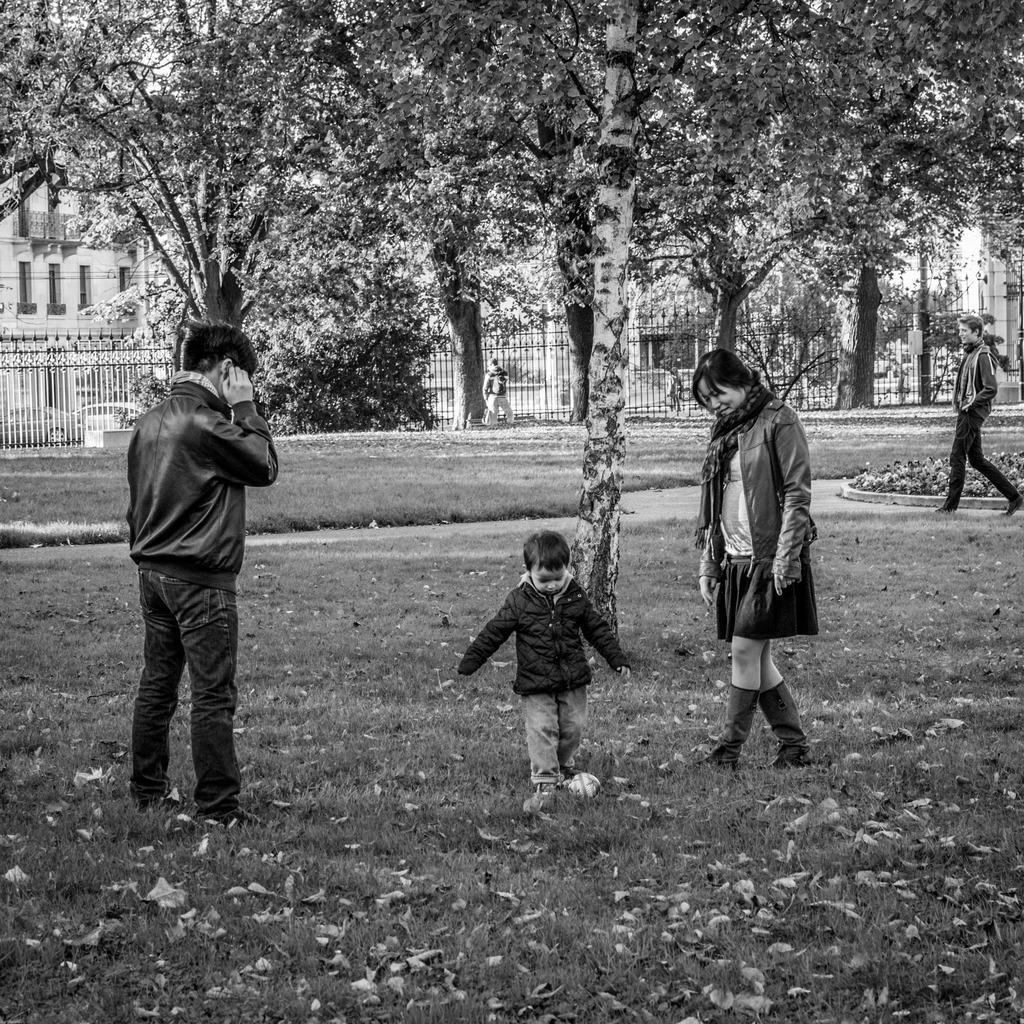What is the surface that the people are standing on in the image? The people are standing on the grass floor in the image. What type of natural elements can be seen in the image? There are trees and plants in the image. What type of structures are visible in the image? There are buildings in the image. What type of barrier is present in the image? There is a fencing in the image. What type of glass can be seen in the image? There is no glass present in the image. What type of farm animals can be seen grazing on the grass in the image? There are no farm animals present in the image; it features people on the grass floor. 